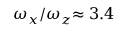<formula> <loc_0><loc_0><loc_500><loc_500>\omega _ { x } / \omega _ { z } { \approx 3 . 4 }</formula> 